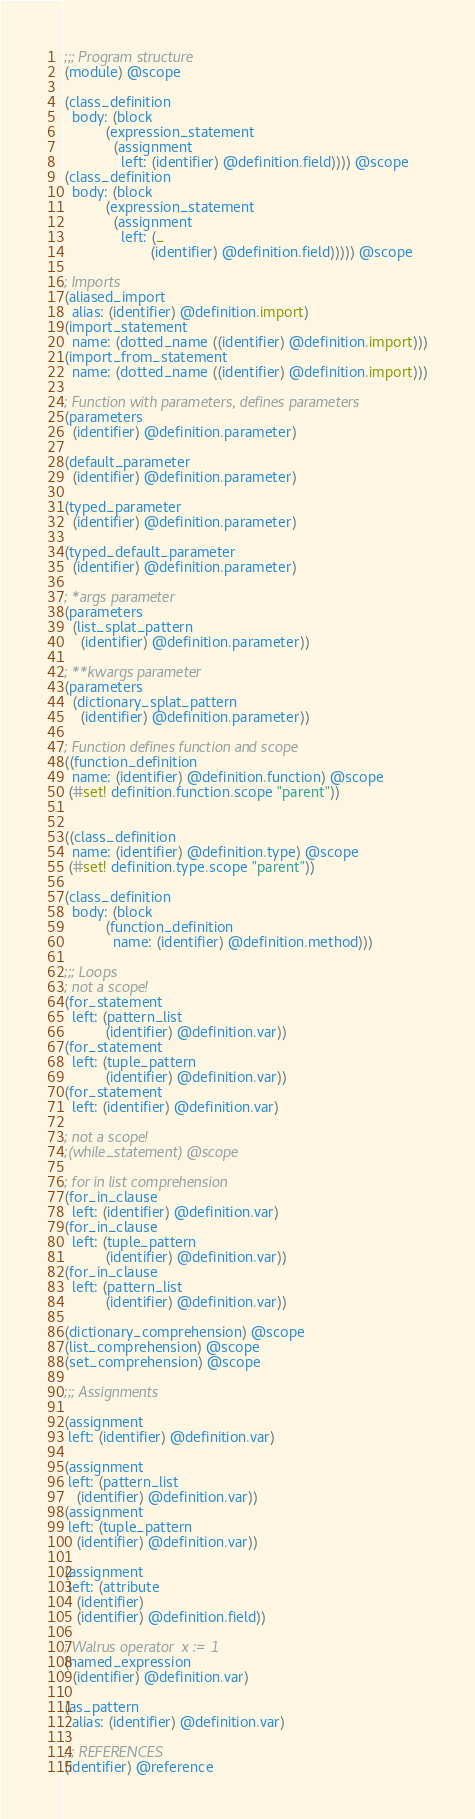<code> <loc_0><loc_0><loc_500><loc_500><_Scheme_>;;; Program structure
(module) @scope

(class_definition
  body: (block
          (expression_statement
            (assignment
              left: (identifier) @definition.field)))) @scope
(class_definition
  body: (block
          (expression_statement
            (assignment
              left: (_ 
                     (identifier) @definition.field))))) @scope

; Imports
(aliased_import
  alias: (identifier) @definition.import)
(import_statement
  name: (dotted_name ((identifier) @definition.import)))
(import_from_statement
  name: (dotted_name ((identifier) @definition.import)))

; Function with parameters, defines parameters
(parameters
  (identifier) @definition.parameter)

(default_parameter
  (identifier) @definition.parameter)

(typed_parameter
  (identifier) @definition.parameter)

(typed_default_parameter
  (identifier) @definition.parameter)

; *args parameter
(parameters
  (list_splat_pattern
    (identifier) @definition.parameter))

; **kwargs parameter
(parameters
  (dictionary_splat_pattern
    (identifier) @definition.parameter))

; Function defines function and scope
((function_definition
  name: (identifier) @definition.function) @scope
 (#set! definition.function.scope "parent"))


((class_definition
  name: (identifier) @definition.type) @scope
 (#set! definition.type.scope "parent"))

(class_definition
  body: (block
          (function_definition
            name: (identifier) @definition.method)))

;;; Loops
; not a scope!
(for_statement
  left: (pattern_list
          (identifier) @definition.var))
(for_statement
  left: (tuple_pattern
          (identifier) @definition.var))
(for_statement
  left: (identifier) @definition.var)

; not a scope!
;(while_statement) @scope

; for in list comprehension
(for_in_clause
  left: (identifier) @definition.var)
(for_in_clause
  left: (tuple_pattern
          (identifier) @definition.var))
(for_in_clause
  left: (pattern_list
          (identifier) @definition.var))

(dictionary_comprehension) @scope
(list_comprehension) @scope
(set_comprehension) @scope

;;; Assignments

(assignment
 left: (identifier) @definition.var)

(assignment
 left: (pattern_list
   (identifier) @definition.var))
(assignment
 left: (tuple_pattern
   (identifier) @definition.var))

(assignment
 left: (attribute
   (identifier)
   (identifier) @definition.field))

; Walrus operator  x := 1
(named_expression
  (identifier) @definition.var)

(as_pattern 
  alias: (identifier) @definition.var)

;;; REFERENCES
(identifier) @reference
</code> 